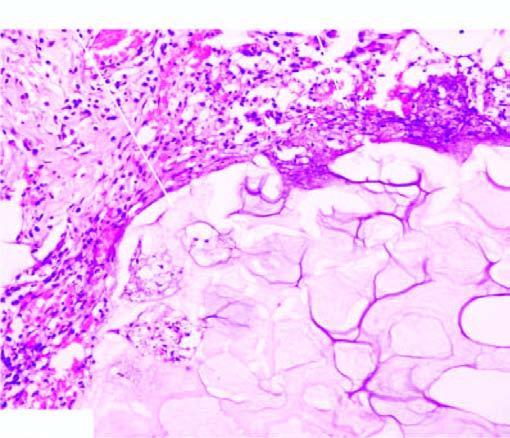what is there?
Answer the question using a single word or phrase. Cloudy appearance of adipocytes 